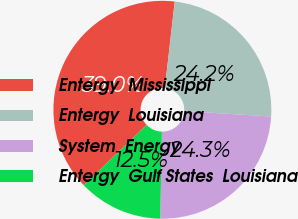<chart> <loc_0><loc_0><loc_500><loc_500><pie_chart><fcel>Entergy  Mississippi<fcel>Entergy  Louisiana<fcel>System  Energy<fcel>Entergy  Gulf States  Louisiana<nl><fcel>38.99%<fcel>24.17%<fcel>24.34%<fcel>12.51%<nl></chart> 